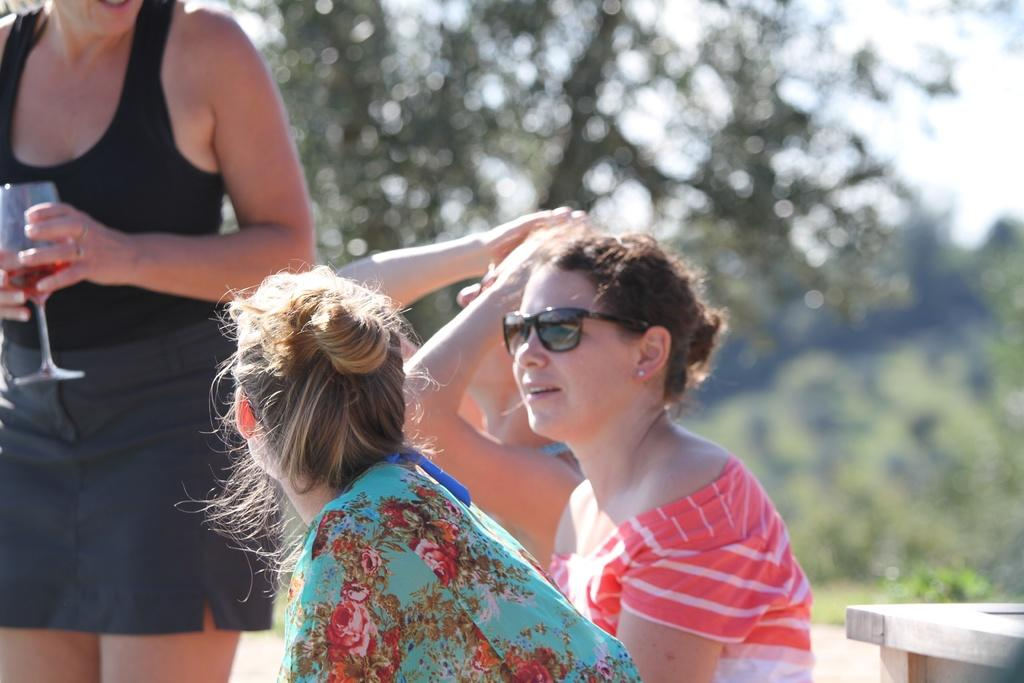Who can be seen in the image? There are people in the image. Can you describe one of the individuals in the image? There is a woman in the image. What is the woman holding in the image? The woman is holding a glass. What can be seen in the background of the image? There are trees in the background of the image. What smell is associated with the woman in the image? There is no information about smells in the image, so it cannot be determined. 